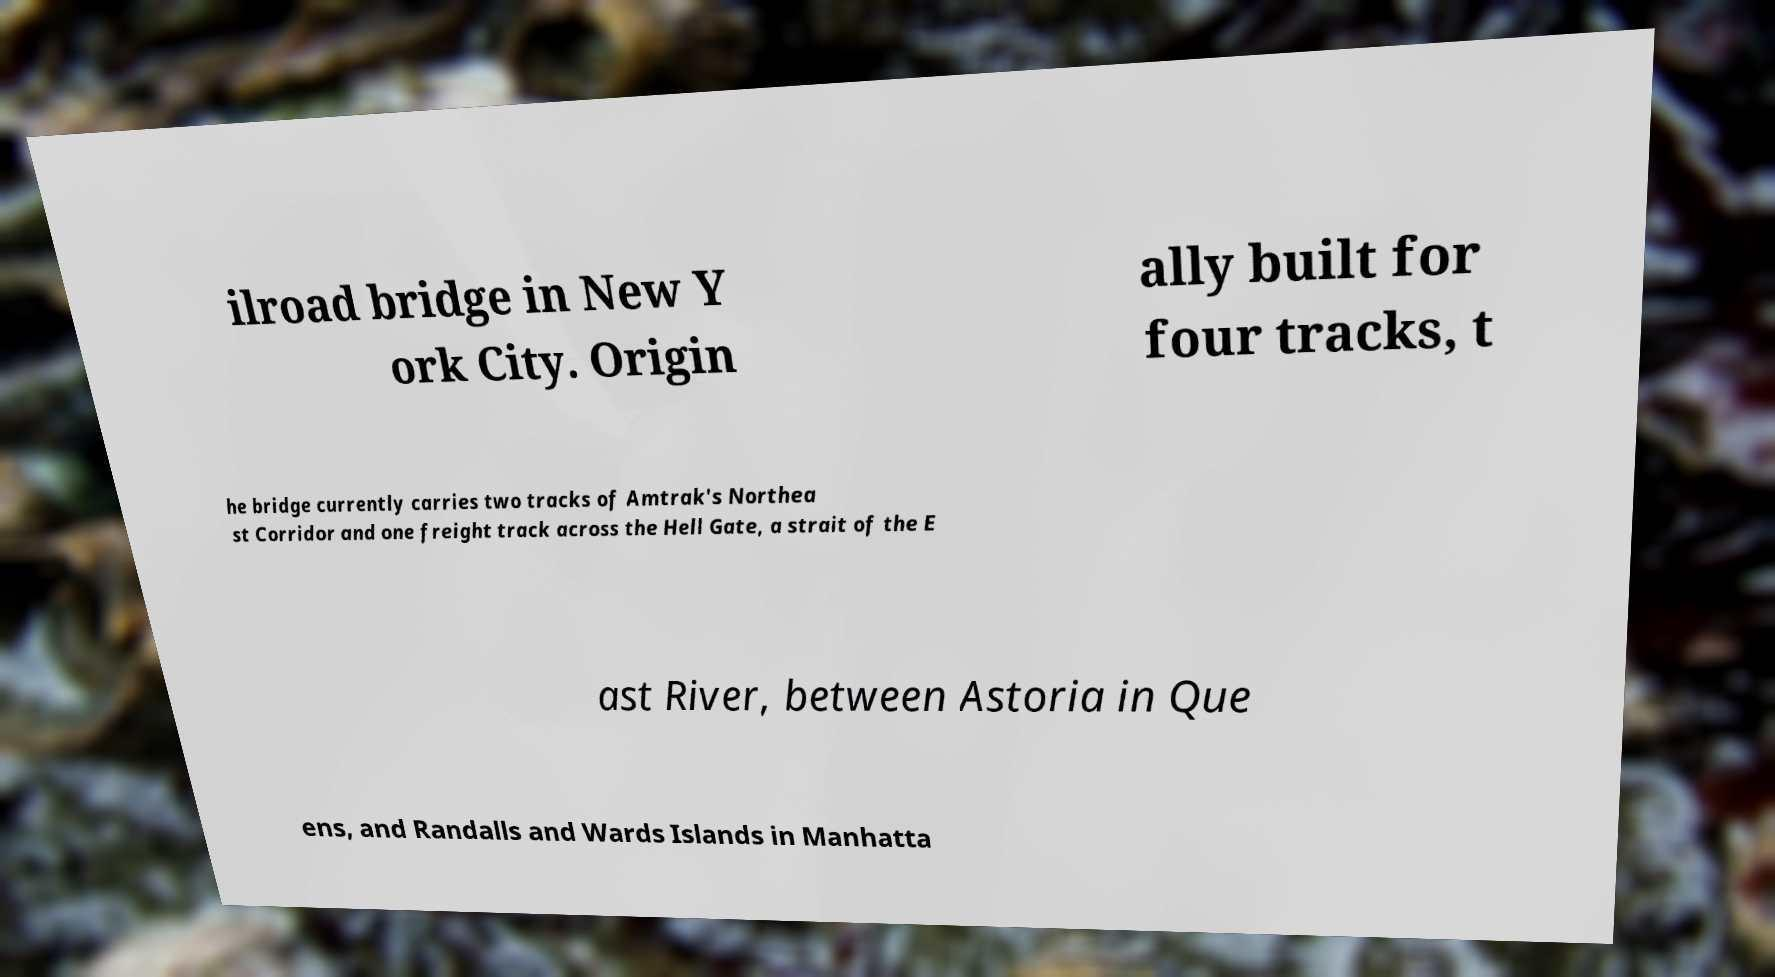I need the written content from this picture converted into text. Can you do that? ilroad bridge in New Y ork City. Origin ally built for four tracks, t he bridge currently carries two tracks of Amtrak's Northea st Corridor and one freight track across the Hell Gate, a strait of the E ast River, between Astoria in Que ens, and Randalls and Wards Islands in Manhatta 